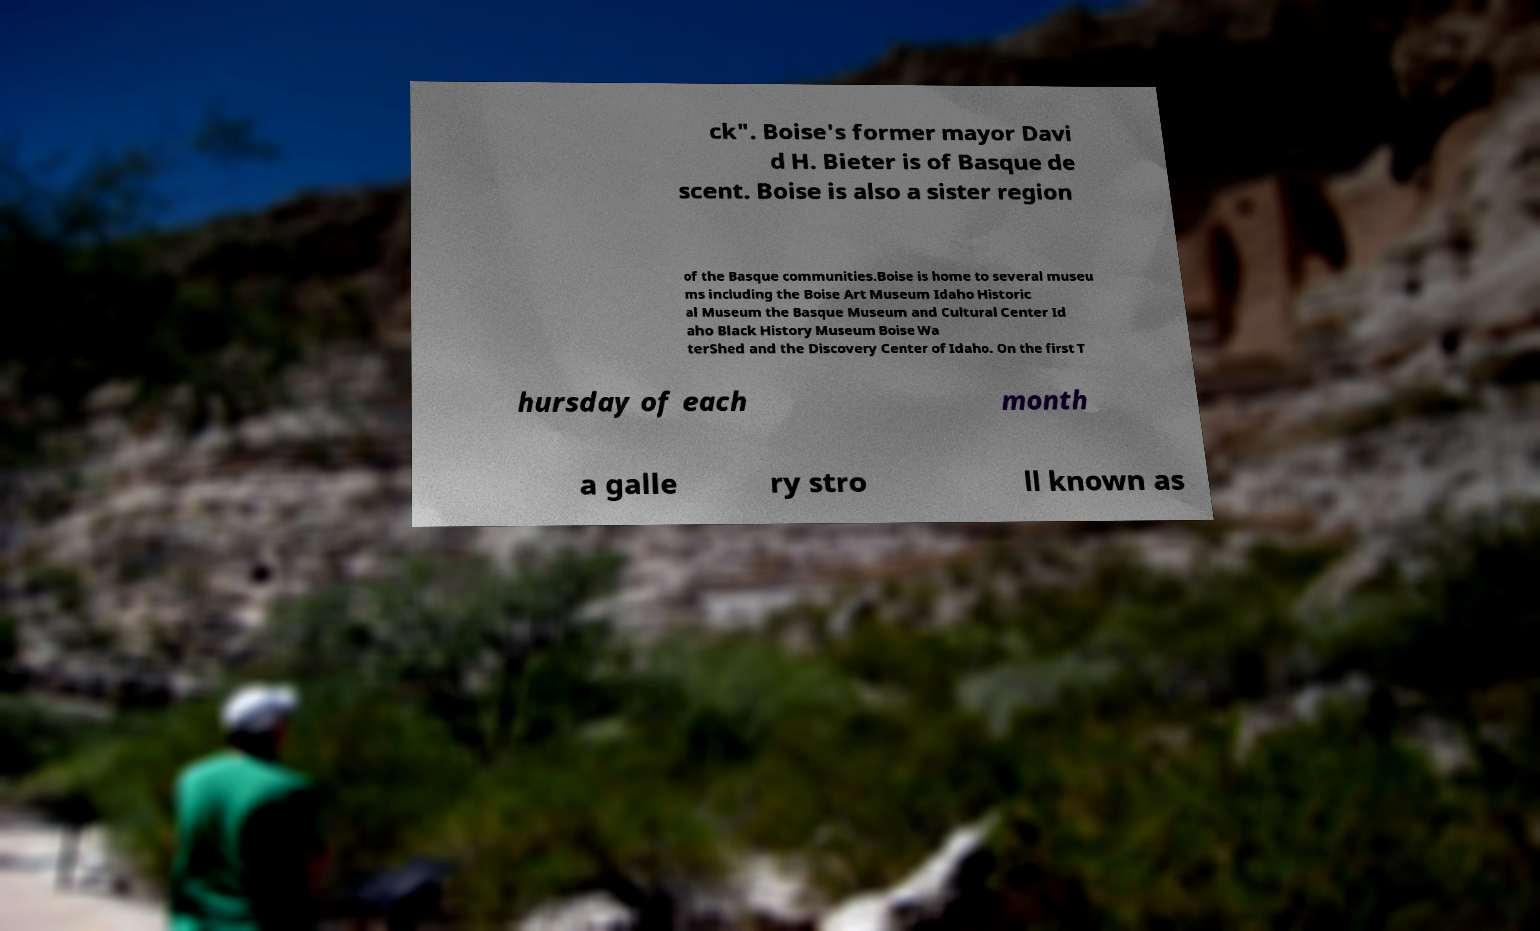Can you read and provide the text displayed in the image?This photo seems to have some interesting text. Can you extract and type it out for me? ck". Boise's former mayor Davi d H. Bieter is of Basque de scent. Boise is also a sister region of the Basque communities.Boise is home to several museu ms including the Boise Art Museum Idaho Historic al Museum the Basque Museum and Cultural Center Id aho Black History Museum Boise Wa terShed and the Discovery Center of Idaho. On the first T hursday of each month a galle ry stro ll known as 